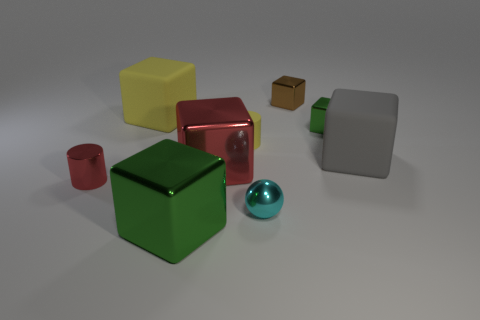Is the large green thing made of the same material as the tiny cube that is right of the small brown cube?
Offer a terse response. Yes. The green metallic thing that is right of the small sphere has what shape?
Keep it short and to the point. Cube. What number of other objects are the same material as the red cube?
Provide a succinct answer. 5. The red cylinder is what size?
Provide a succinct answer. Small. What number of other objects are the same color as the metal cylinder?
Ensure brevity in your answer.  1. There is a rubber object that is both in front of the big yellow block and left of the ball; what color is it?
Your answer should be very brief. Yellow. What number of rubber cubes are there?
Ensure brevity in your answer.  2. Is the material of the small brown object the same as the tiny red cylinder?
Your answer should be very brief. Yes. What is the shape of the big rubber thing on the left side of the rubber cube that is to the right of the large metallic thing that is in front of the tiny red object?
Your response must be concise. Cube. Is the material of the cylinder to the left of the small rubber thing the same as the small object that is in front of the metallic cylinder?
Give a very brief answer. Yes. 